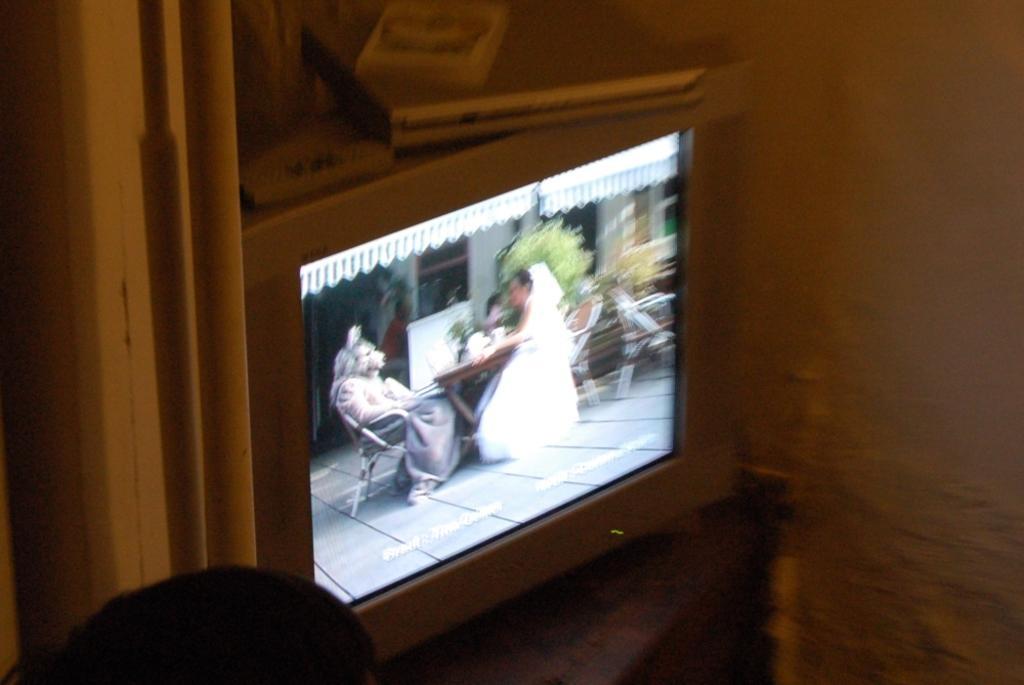Please provide a concise description of this image. In this image we can see a television screen. In the screen there are persons sitting on the chairs and a table is placed in front of them. In the background we can see shed, building, chairs and plants. 